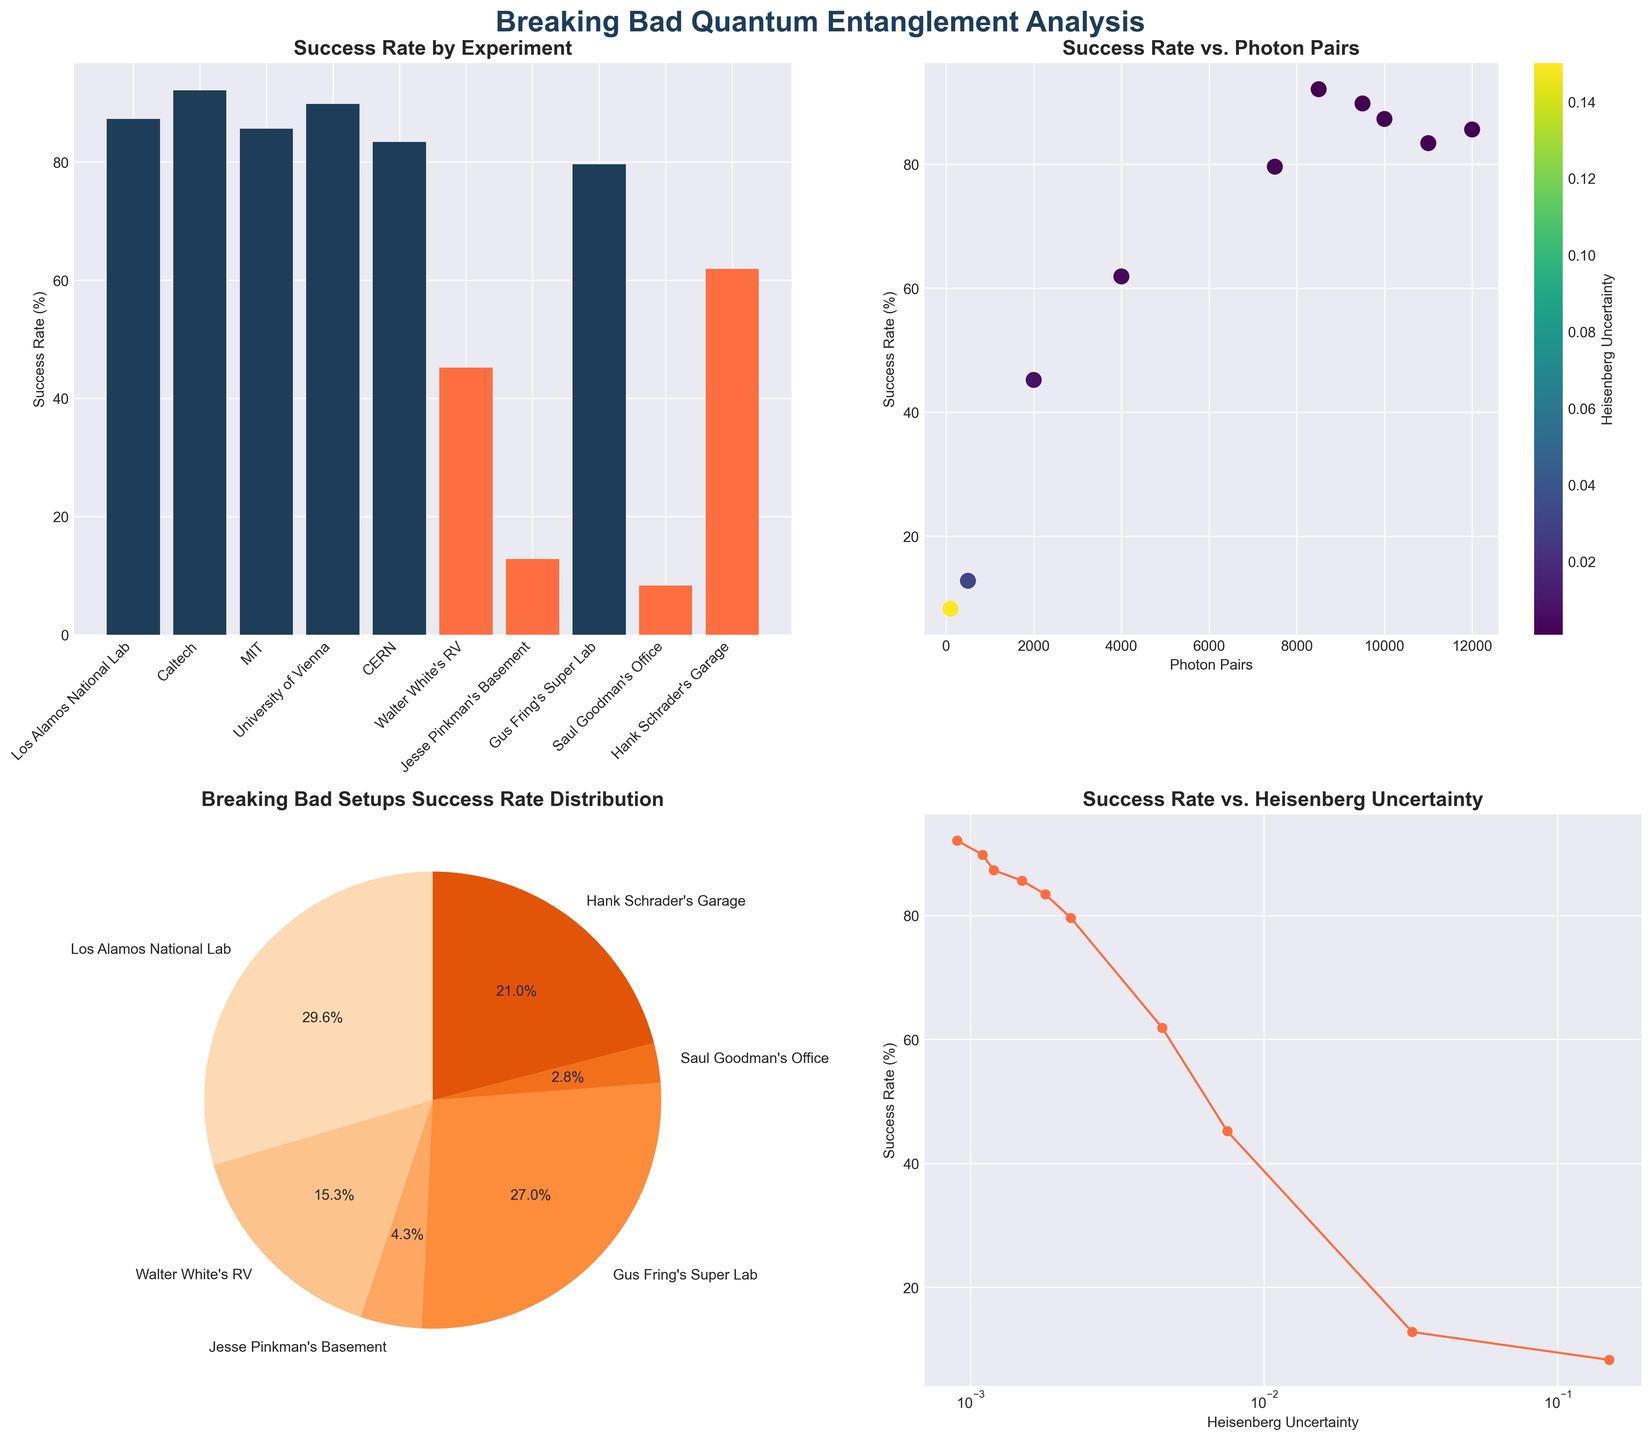What is the title of the bar plot? The title of the bar plot is displayed above the bar plot and is written in a bold, larger font size.
Answer: Success Rate by Experiment What are the x-axis labels of the bar plot? The x-axis labels of the bar plot represent the different experiments included in the dataset such as 'Los Alamos National Lab', 'Caltech', 'MIT', etc.
Answer: Los Alamos National Lab, Caltech, MIT, University of Vienna, CERN, Walter White's RV, Jesse Pinkman's Basement, Gus Fring's Super Lab, Saul Goodman's Office, Hank Schrader's Garage Which experimental setup has the highest success rate in the bar plot? The success rate is indicated by the height of the bars, and the highest bar corresponds to 'Caltech' with a success rate roughly around 92.1%.
Answer: Caltech What is the color mapping used in the scatter plot? The scatter plot uses a colormap (viridis) to represent the Heisenberg Uncertainty, and it is displayed via a color legend next to the plot. Darker colors represent lower values of Heisenberg Uncertainty while lighter colors represent higher values.
Answer: Viridis colormap indicating Heisenberg Uncertainty Which experiment has the highest Heisenberg Uncertainty in the scatter plot? The highest Heisenberg Uncertainty can be observed through the color legend; the brightest points on the plot represent the highest uncertainty. 'Saul Goodman's Office' has the highest uncertainty value of 0.1500.
Answer: Saul Goodman's Office How many experimental setups from Breaking Bad are included in the pie chart? By looking at the labels and sections of the pie chart, we can count the segments directly related to Breaking Bad setups: Walter White's RV, Jesse Pinkman's Basement, Gus Fring's Super Lab, Saul Goodman's Office, and Hank Schrader's Garage.
Answer: Five What trend do you observe between Heisenberg Uncertainty and Success Rate in the line plot? The line plot shows Success Rate on the y-axis and Heisenberg Uncertainty on the x-axis (log scale). Overall, there is a negative trend where higher Heisenberg Uncertainty corresponds to a lower Success Rate.
Answer: Negative trend Which experiments have a higher success rate than 'Gus Fring's Super Lab' in the bar plot? By comparing the height of the bars in the bar plot, we see that 'Los Alamos National Lab', 'Caltech', 'MIT', and 'University of Vienna' have higher success rates than 'Gus Fring’s Super Lab' (79.6%).
Answer: Los Alamos National Lab, Caltech, University of Vienna What is the sum of the success rates of all Breaking Bad setups in the pie chart? The pie chart segments for Breaking Bad setups display these success rates: 45.2 (RV) + 12.8 (Basement) + 79.6 (Super Lab) + 8.3 (Office) + 61.9 (Garage). Adding these rates gives a total.
Answer: 207.8% 